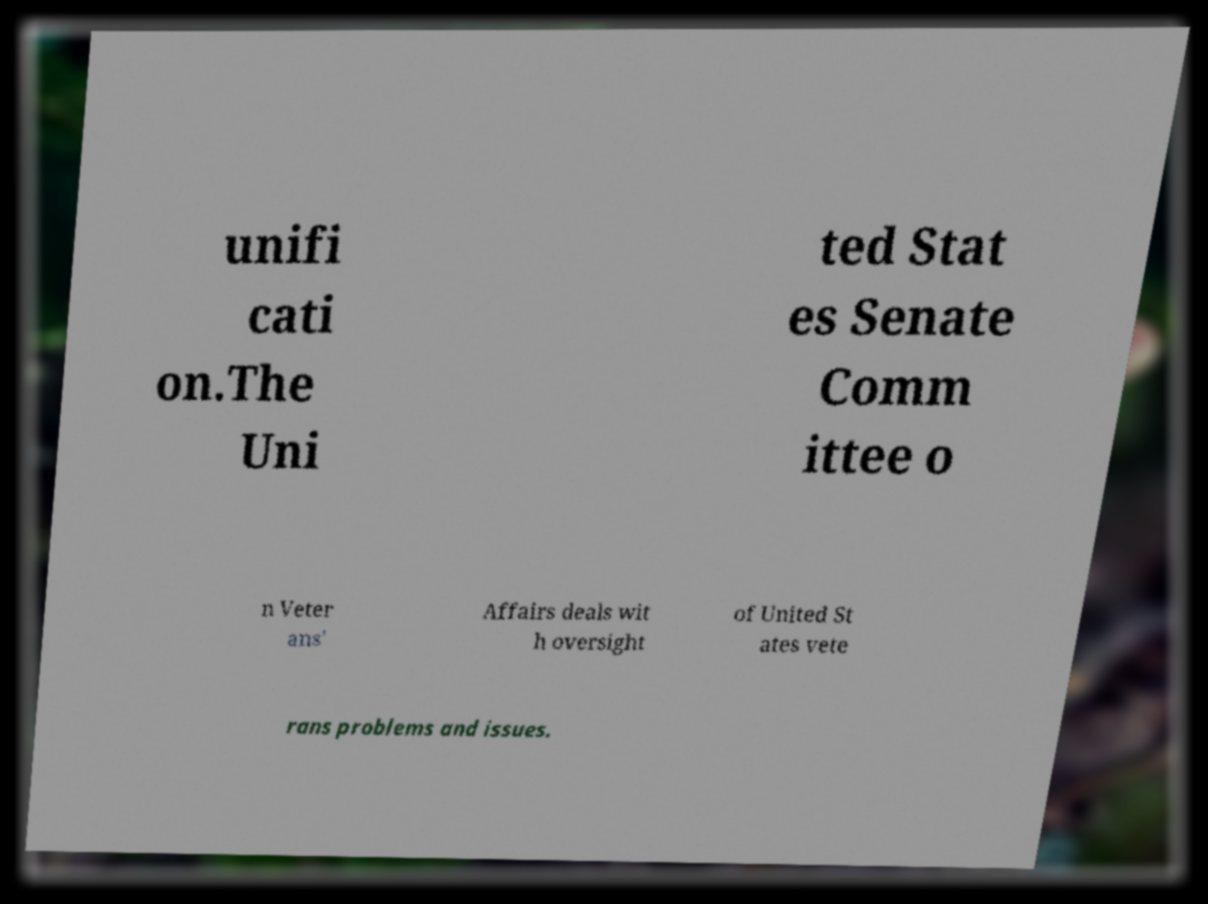Please read and relay the text visible in this image. What does it say? unifi cati on.The Uni ted Stat es Senate Comm ittee o n Veter ans' Affairs deals wit h oversight of United St ates vete rans problems and issues. 